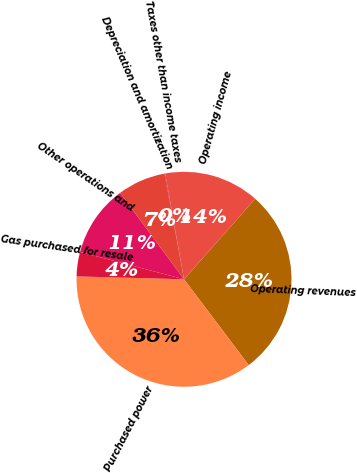Convert chart to OTSL. <chart><loc_0><loc_0><loc_500><loc_500><pie_chart><fcel>Operating revenues<fcel>Purchased power<fcel>Gas purchased for resale<fcel>Other operations and<fcel>Depreciation and amortization<fcel>Taxes other than income taxes<fcel>Operating income<nl><fcel>28.19%<fcel>35.71%<fcel>3.66%<fcel>10.78%<fcel>7.22%<fcel>0.1%<fcel>14.34%<nl></chart> 